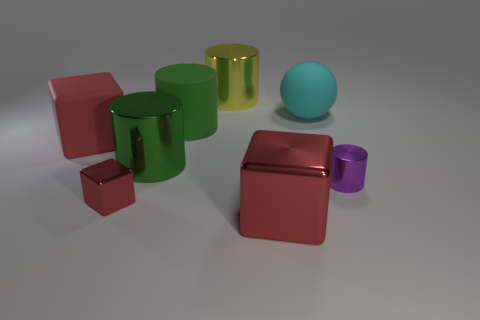Can you describe the textures of the objects? The objects appear to have a smooth texture with a reflective surface, suggesting that they are made of materials like polished metal or plastic. The light reflects differently on each one, indicating various levels of glossiness across the objects. 